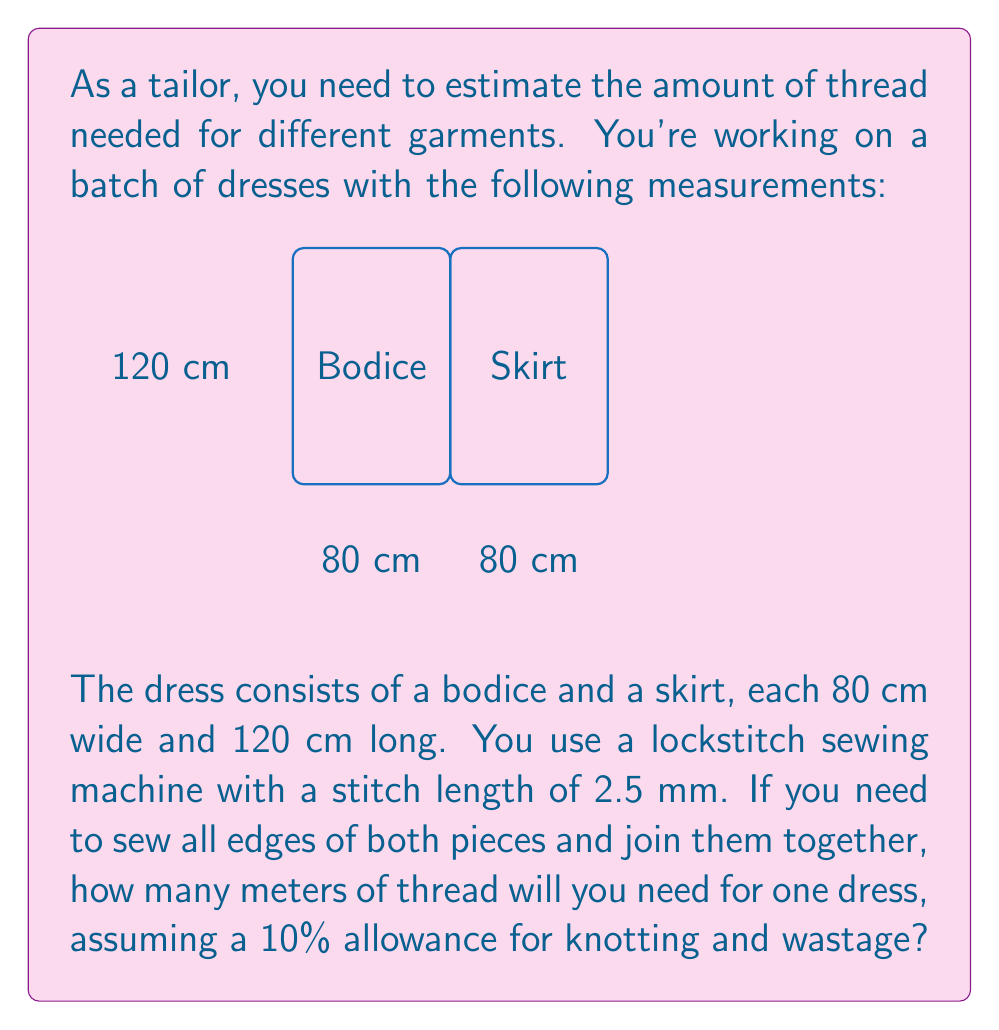Give your solution to this math problem. Let's break this down step-by-step:

1) Calculate the total length of seams to be sewn:
   - Bodice perimeter: $2(80 + 120) = 400$ cm
   - Skirt perimeter: $2(80 + 120) = 400$ cm
   - Joining bodice and skirt: $80$ cm
   Total seam length: $400 + 400 + 80 = 880$ cm

2) Convert stitch length from mm to cm:
   $2.5$ mm $= 0.25$ cm

3) Calculate the number of stitches:
   $\text{Number of stitches} = \frac{\text{Total seam length}}{\text{Stitch length}} = \frac{880}{0.25} = 3520$ stitches

4) In a lockstitch, each stitch uses twice the visible thread length:
   $\text{Thread length} = 2 \times 3520 \times 0.25 = 1760$ cm

5) Convert to meters:
   $1760$ cm $= 17.6$ m

6) Add 10% allowance:
   $17.6 \times 1.1 = 19.36$ m

Therefore, you'll need approximately 19.36 meters of thread for one dress.
Answer: 19.36 m 